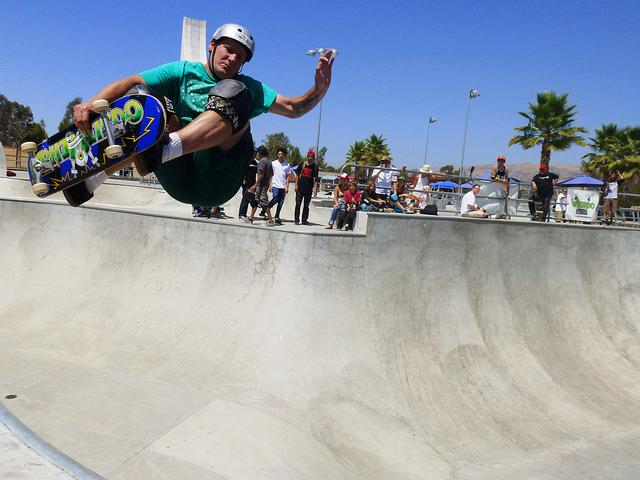What is this skateboarding feature? Please explain your reasoning. half-pipe. The half pipe is present. 